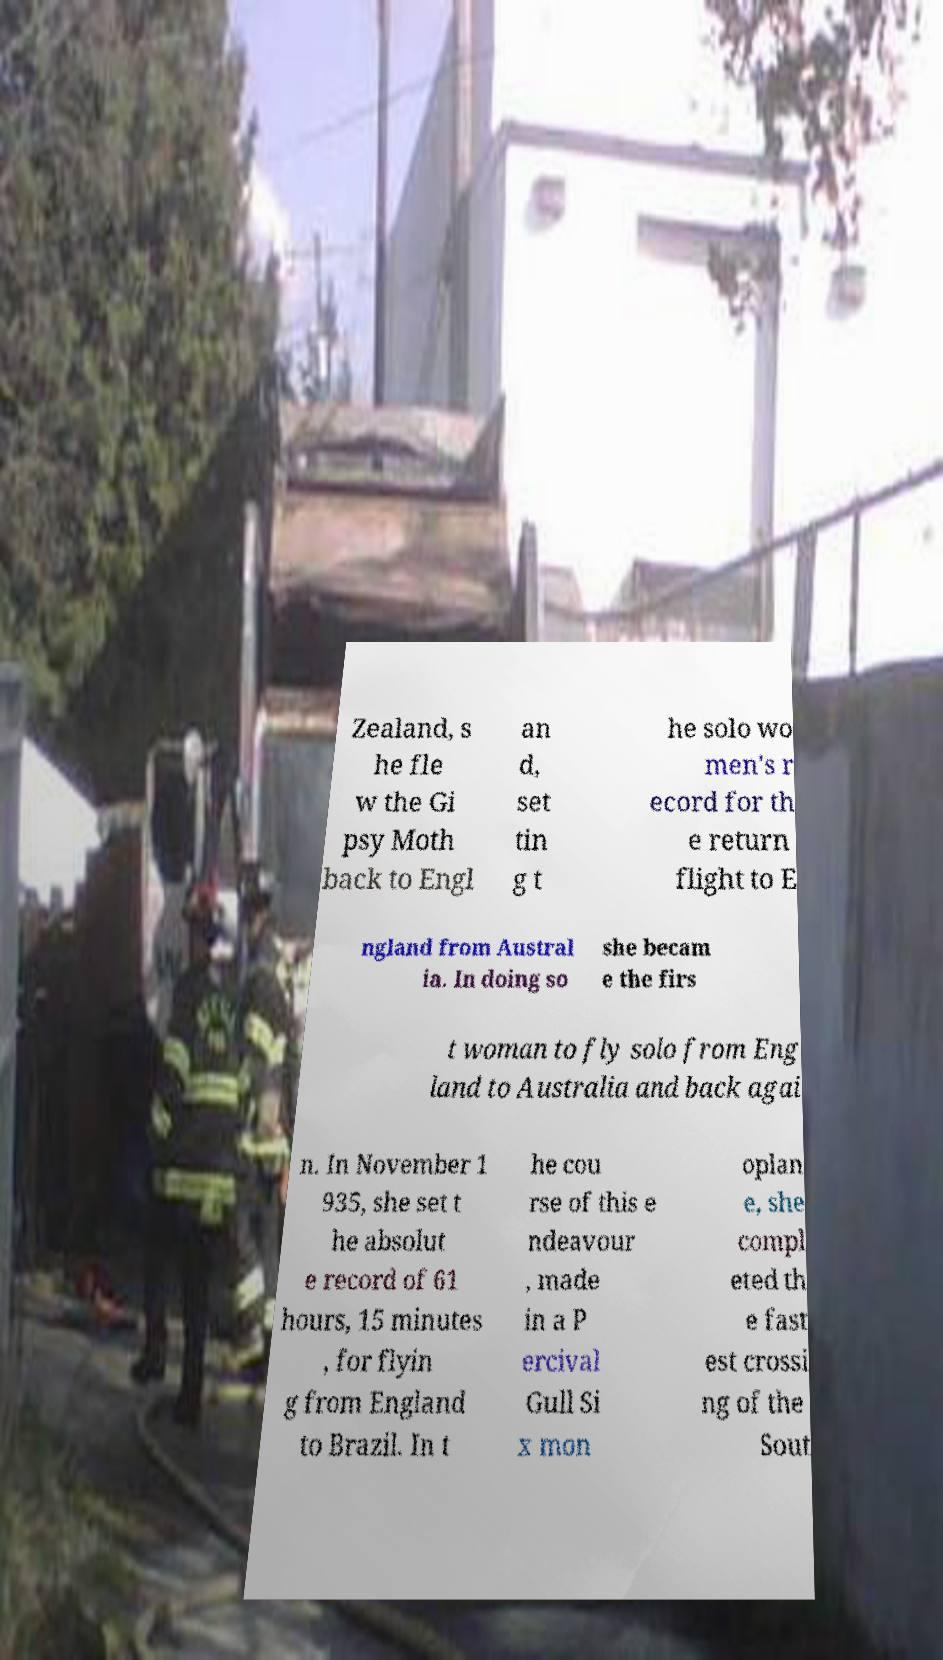Could you assist in decoding the text presented in this image and type it out clearly? Zealand, s he fle w the Gi psy Moth back to Engl an d, set tin g t he solo wo men's r ecord for th e return flight to E ngland from Austral ia. In doing so she becam e the firs t woman to fly solo from Eng land to Australia and back agai n. In November 1 935, she set t he absolut e record of 61 hours, 15 minutes , for flyin g from England to Brazil. In t he cou rse of this e ndeavour , made in a P ercival Gull Si x mon oplan e, she compl eted th e fast est crossi ng of the Sout 